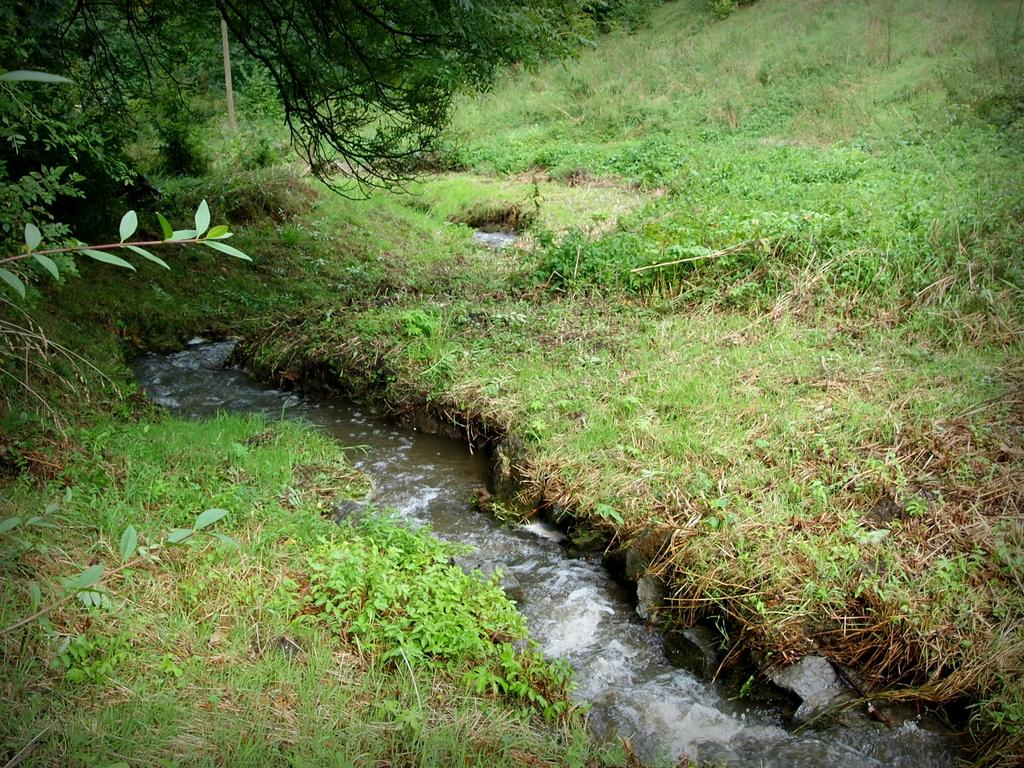What type of vegetation can be seen in the image? There is green grass and plants visible in the image. What is the color of the grass in the image? The grass in the image is green. What else can be seen in the image besides the grass and plants? There is water visible in the image. What feature of the plants can be observed in the image? Leaves are present on the stems of the plants. What type of government is depicted in the image? There is no government depicted in the image; it features green grass, plants, and water. Who is the manager of the plants in the image? There is no manager present in the image; it is a natural scene with plants and grass. 